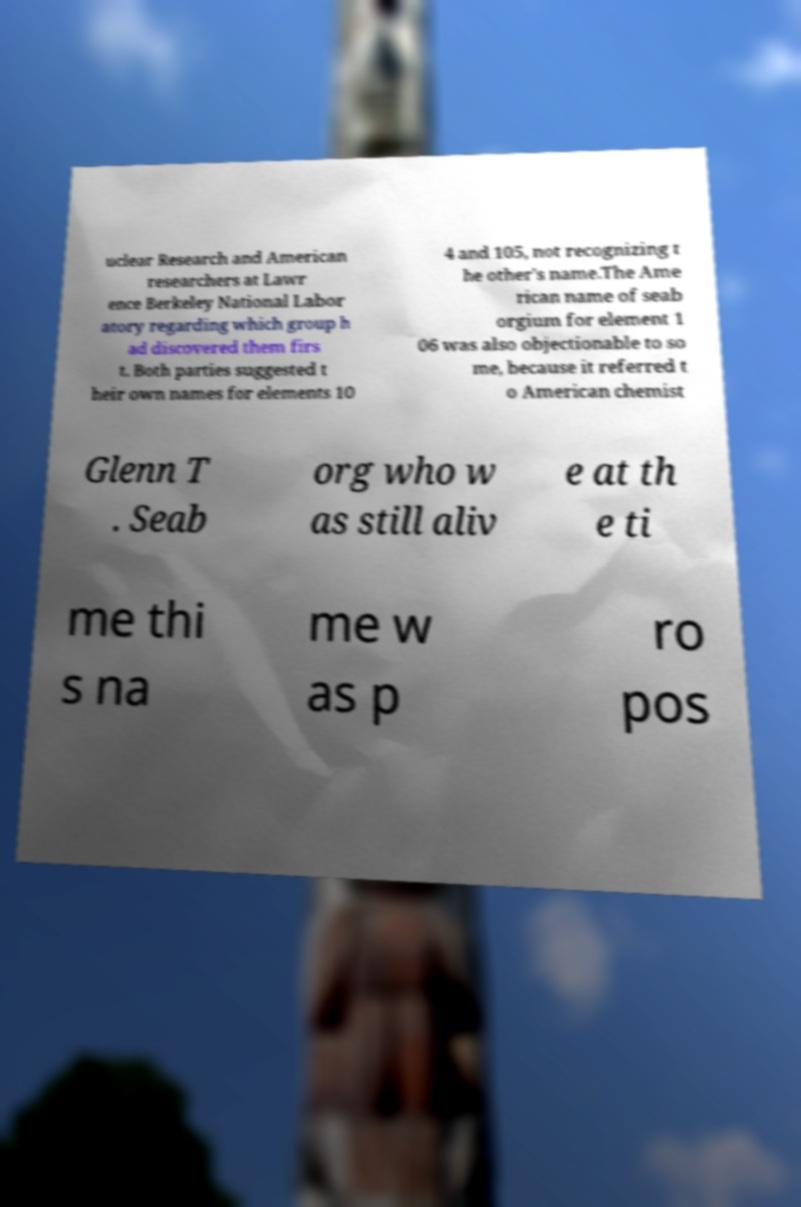For documentation purposes, I need the text within this image transcribed. Could you provide that? uclear Research and American researchers at Lawr ence Berkeley National Labor atory regarding which group h ad discovered them firs t. Both parties suggested t heir own names for elements 10 4 and 105, not recognizing t he other's name.The Ame rican name of seab orgium for element 1 06 was also objectionable to so me, because it referred t o American chemist Glenn T . Seab org who w as still aliv e at th e ti me thi s na me w as p ro pos 